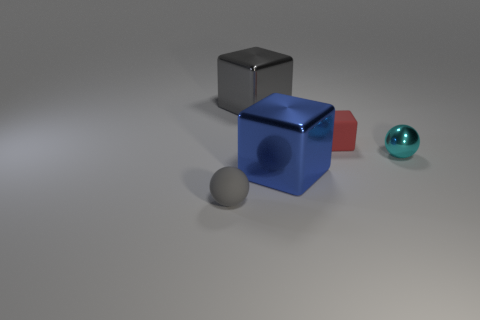Add 4 blue blocks. How many objects exist? 9 Subtract all big gray metallic blocks. How many blocks are left? 2 Subtract all blue cubes. How many cubes are left? 2 Add 2 gray spheres. How many gray spheres exist? 3 Subtract 0 blue spheres. How many objects are left? 5 Subtract all blocks. How many objects are left? 2 Subtract all green blocks. Subtract all yellow spheres. How many blocks are left? 3 Subtract all red cylinders. How many gray blocks are left? 1 Subtract all balls. Subtract all big blue metal cubes. How many objects are left? 2 Add 2 large blue metallic objects. How many large blue metallic objects are left? 3 